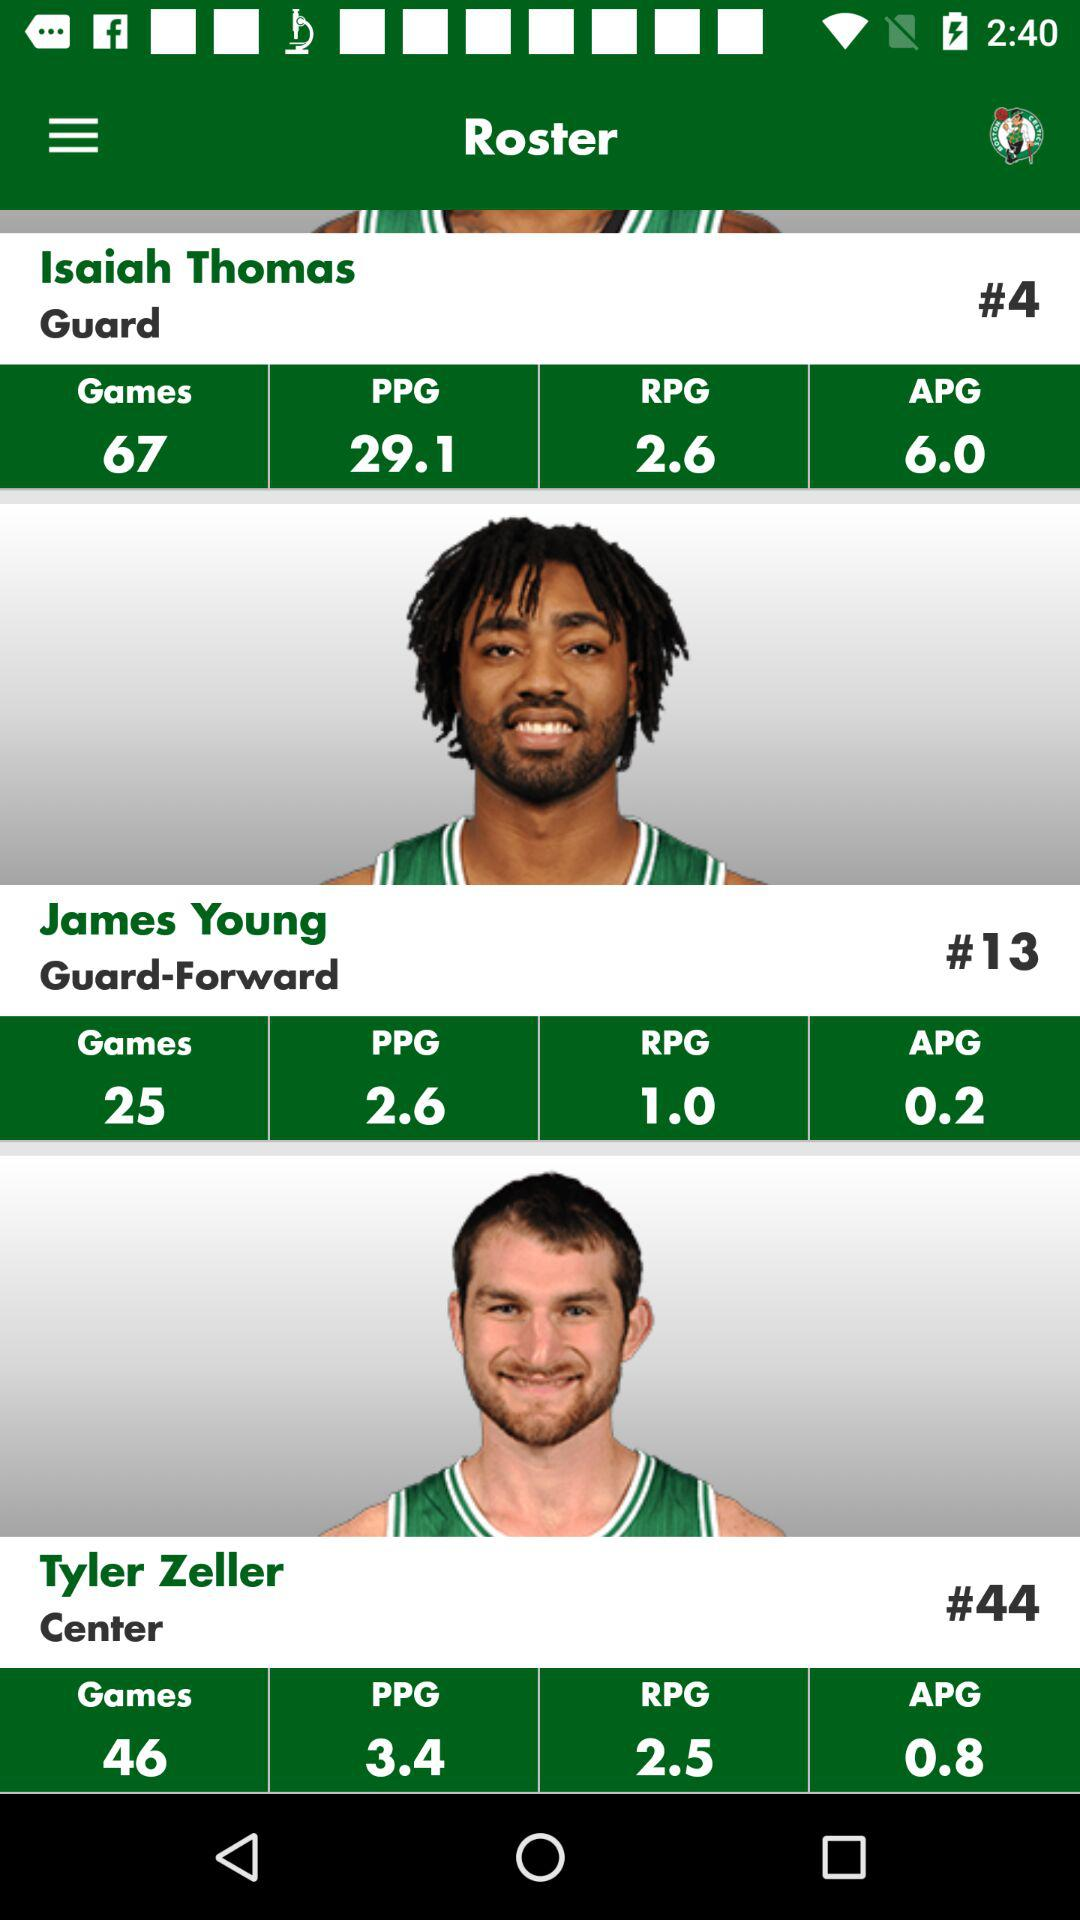What is the T-shirt number of James Young?
When the provided information is insufficient, respond with <no answer>. <no answer> 